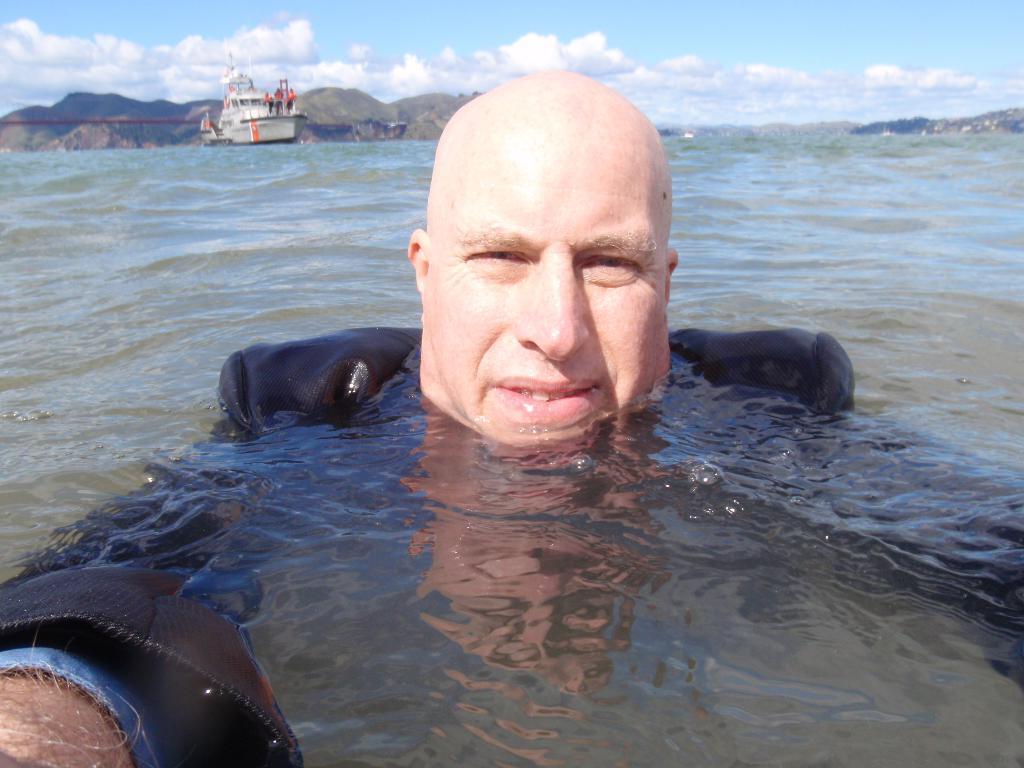In one or two sentences, can you explain what this image depicts? The man in front of the picture wearing blue jacket is in the water and I think he might be swimming and taking photo. Behind him, we see a steamer and in the background, there are hills. At the top of the picture, we see the sky and clouds. 